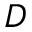Convert formula to latex. <formula><loc_0><loc_0><loc_500><loc_500>D</formula> 